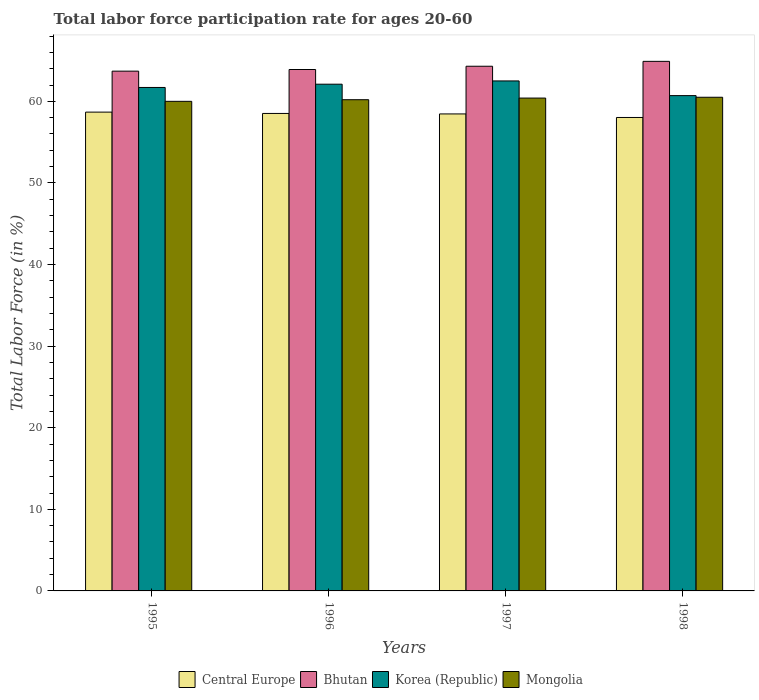Are the number of bars per tick equal to the number of legend labels?
Make the answer very short. Yes. Are the number of bars on each tick of the X-axis equal?
Provide a succinct answer. Yes. How many bars are there on the 2nd tick from the right?
Ensure brevity in your answer.  4. What is the label of the 4th group of bars from the left?
Make the answer very short. 1998. What is the labor force participation rate in Korea (Republic) in 1995?
Your answer should be very brief. 61.7. Across all years, what is the maximum labor force participation rate in Central Europe?
Offer a terse response. 58.68. Across all years, what is the minimum labor force participation rate in Korea (Republic)?
Your answer should be compact. 60.7. In which year was the labor force participation rate in Korea (Republic) maximum?
Give a very brief answer. 1997. In which year was the labor force participation rate in Mongolia minimum?
Your answer should be compact. 1995. What is the total labor force participation rate in Central Europe in the graph?
Offer a very short reply. 233.67. What is the difference between the labor force participation rate in Central Europe in 1996 and that in 1997?
Offer a terse response. 0.06. What is the difference between the labor force participation rate in Central Europe in 1998 and the labor force participation rate in Mongolia in 1995?
Ensure brevity in your answer.  -1.98. What is the average labor force participation rate in Mongolia per year?
Offer a very short reply. 60.28. In the year 1995, what is the difference between the labor force participation rate in Central Europe and labor force participation rate in Korea (Republic)?
Keep it short and to the point. -3.02. In how many years, is the labor force participation rate in Central Europe greater than 24 %?
Offer a terse response. 4. What is the ratio of the labor force participation rate in Korea (Republic) in 1996 to that in 1997?
Provide a short and direct response. 0.99. Is the labor force participation rate in Mongolia in 1995 less than that in 1998?
Your response must be concise. Yes. Is the difference between the labor force participation rate in Central Europe in 1996 and 1997 greater than the difference between the labor force participation rate in Korea (Republic) in 1996 and 1997?
Make the answer very short. Yes. What is the difference between the highest and the second highest labor force participation rate in Central Europe?
Offer a terse response. 0.16. What is the difference between the highest and the lowest labor force participation rate in Korea (Republic)?
Provide a short and direct response. 1.8. What does the 1st bar from the left in 1995 represents?
Your answer should be very brief. Central Europe. What does the 1st bar from the right in 1995 represents?
Offer a terse response. Mongolia. Is it the case that in every year, the sum of the labor force participation rate in Korea (Republic) and labor force participation rate in Bhutan is greater than the labor force participation rate in Mongolia?
Offer a very short reply. Yes. How many bars are there?
Your answer should be compact. 16. Are all the bars in the graph horizontal?
Make the answer very short. No. How many years are there in the graph?
Provide a short and direct response. 4. What is the difference between two consecutive major ticks on the Y-axis?
Your answer should be very brief. 10. Does the graph contain any zero values?
Your response must be concise. No. Does the graph contain grids?
Make the answer very short. No. Where does the legend appear in the graph?
Your response must be concise. Bottom center. How many legend labels are there?
Offer a terse response. 4. How are the legend labels stacked?
Your answer should be compact. Horizontal. What is the title of the graph?
Ensure brevity in your answer.  Total labor force participation rate for ages 20-60. What is the label or title of the X-axis?
Provide a succinct answer. Years. What is the Total Labor Force (in %) of Central Europe in 1995?
Give a very brief answer. 58.68. What is the Total Labor Force (in %) of Bhutan in 1995?
Ensure brevity in your answer.  63.7. What is the Total Labor Force (in %) in Korea (Republic) in 1995?
Provide a short and direct response. 61.7. What is the Total Labor Force (in %) of Mongolia in 1995?
Ensure brevity in your answer.  60. What is the Total Labor Force (in %) in Central Europe in 1996?
Your answer should be compact. 58.52. What is the Total Labor Force (in %) in Bhutan in 1996?
Make the answer very short. 63.9. What is the Total Labor Force (in %) in Korea (Republic) in 1996?
Offer a very short reply. 62.1. What is the Total Labor Force (in %) of Mongolia in 1996?
Your response must be concise. 60.2. What is the Total Labor Force (in %) of Central Europe in 1997?
Provide a short and direct response. 58.46. What is the Total Labor Force (in %) in Bhutan in 1997?
Provide a short and direct response. 64.3. What is the Total Labor Force (in %) in Korea (Republic) in 1997?
Provide a short and direct response. 62.5. What is the Total Labor Force (in %) in Mongolia in 1997?
Give a very brief answer. 60.4. What is the Total Labor Force (in %) of Central Europe in 1998?
Your answer should be very brief. 58.02. What is the Total Labor Force (in %) of Bhutan in 1998?
Make the answer very short. 64.9. What is the Total Labor Force (in %) of Korea (Republic) in 1998?
Provide a short and direct response. 60.7. What is the Total Labor Force (in %) of Mongolia in 1998?
Provide a short and direct response. 60.5. Across all years, what is the maximum Total Labor Force (in %) of Central Europe?
Keep it short and to the point. 58.68. Across all years, what is the maximum Total Labor Force (in %) in Bhutan?
Provide a short and direct response. 64.9. Across all years, what is the maximum Total Labor Force (in %) in Korea (Republic)?
Keep it short and to the point. 62.5. Across all years, what is the maximum Total Labor Force (in %) of Mongolia?
Make the answer very short. 60.5. Across all years, what is the minimum Total Labor Force (in %) of Central Europe?
Provide a succinct answer. 58.02. Across all years, what is the minimum Total Labor Force (in %) in Bhutan?
Ensure brevity in your answer.  63.7. Across all years, what is the minimum Total Labor Force (in %) of Korea (Republic)?
Your response must be concise. 60.7. Across all years, what is the minimum Total Labor Force (in %) of Mongolia?
Give a very brief answer. 60. What is the total Total Labor Force (in %) in Central Europe in the graph?
Keep it short and to the point. 233.67. What is the total Total Labor Force (in %) in Bhutan in the graph?
Your answer should be compact. 256.8. What is the total Total Labor Force (in %) of Korea (Republic) in the graph?
Provide a short and direct response. 247. What is the total Total Labor Force (in %) in Mongolia in the graph?
Your answer should be very brief. 241.1. What is the difference between the Total Labor Force (in %) of Central Europe in 1995 and that in 1996?
Keep it short and to the point. 0.16. What is the difference between the Total Labor Force (in %) in Bhutan in 1995 and that in 1996?
Provide a short and direct response. -0.2. What is the difference between the Total Labor Force (in %) in Central Europe in 1995 and that in 1997?
Ensure brevity in your answer.  0.22. What is the difference between the Total Labor Force (in %) in Korea (Republic) in 1995 and that in 1997?
Your answer should be very brief. -0.8. What is the difference between the Total Labor Force (in %) in Central Europe in 1995 and that in 1998?
Your answer should be compact. 0.66. What is the difference between the Total Labor Force (in %) in Bhutan in 1995 and that in 1998?
Give a very brief answer. -1.2. What is the difference between the Total Labor Force (in %) in Central Europe in 1996 and that in 1997?
Make the answer very short. 0.06. What is the difference between the Total Labor Force (in %) of Korea (Republic) in 1996 and that in 1997?
Ensure brevity in your answer.  -0.4. What is the difference between the Total Labor Force (in %) in Central Europe in 1996 and that in 1998?
Provide a succinct answer. 0.49. What is the difference between the Total Labor Force (in %) in Bhutan in 1996 and that in 1998?
Your answer should be very brief. -1. What is the difference between the Total Labor Force (in %) in Korea (Republic) in 1996 and that in 1998?
Provide a succinct answer. 1.4. What is the difference between the Total Labor Force (in %) of Central Europe in 1997 and that in 1998?
Your answer should be compact. 0.44. What is the difference between the Total Labor Force (in %) of Bhutan in 1997 and that in 1998?
Provide a short and direct response. -0.6. What is the difference between the Total Labor Force (in %) of Central Europe in 1995 and the Total Labor Force (in %) of Bhutan in 1996?
Make the answer very short. -5.22. What is the difference between the Total Labor Force (in %) of Central Europe in 1995 and the Total Labor Force (in %) of Korea (Republic) in 1996?
Your answer should be very brief. -3.42. What is the difference between the Total Labor Force (in %) in Central Europe in 1995 and the Total Labor Force (in %) in Mongolia in 1996?
Keep it short and to the point. -1.52. What is the difference between the Total Labor Force (in %) of Central Europe in 1995 and the Total Labor Force (in %) of Bhutan in 1997?
Ensure brevity in your answer.  -5.62. What is the difference between the Total Labor Force (in %) of Central Europe in 1995 and the Total Labor Force (in %) of Korea (Republic) in 1997?
Provide a short and direct response. -3.82. What is the difference between the Total Labor Force (in %) of Central Europe in 1995 and the Total Labor Force (in %) of Mongolia in 1997?
Offer a terse response. -1.72. What is the difference between the Total Labor Force (in %) in Bhutan in 1995 and the Total Labor Force (in %) in Korea (Republic) in 1997?
Provide a short and direct response. 1.2. What is the difference between the Total Labor Force (in %) of Central Europe in 1995 and the Total Labor Force (in %) of Bhutan in 1998?
Make the answer very short. -6.22. What is the difference between the Total Labor Force (in %) in Central Europe in 1995 and the Total Labor Force (in %) in Korea (Republic) in 1998?
Give a very brief answer. -2.02. What is the difference between the Total Labor Force (in %) in Central Europe in 1995 and the Total Labor Force (in %) in Mongolia in 1998?
Your answer should be very brief. -1.82. What is the difference between the Total Labor Force (in %) of Bhutan in 1995 and the Total Labor Force (in %) of Korea (Republic) in 1998?
Offer a very short reply. 3. What is the difference between the Total Labor Force (in %) of Korea (Republic) in 1995 and the Total Labor Force (in %) of Mongolia in 1998?
Give a very brief answer. 1.2. What is the difference between the Total Labor Force (in %) of Central Europe in 1996 and the Total Labor Force (in %) of Bhutan in 1997?
Provide a succinct answer. -5.78. What is the difference between the Total Labor Force (in %) of Central Europe in 1996 and the Total Labor Force (in %) of Korea (Republic) in 1997?
Your answer should be compact. -3.98. What is the difference between the Total Labor Force (in %) in Central Europe in 1996 and the Total Labor Force (in %) in Mongolia in 1997?
Give a very brief answer. -1.88. What is the difference between the Total Labor Force (in %) in Central Europe in 1996 and the Total Labor Force (in %) in Bhutan in 1998?
Your response must be concise. -6.38. What is the difference between the Total Labor Force (in %) of Central Europe in 1996 and the Total Labor Force (in %) of Korea (Republic) in 1998?
Your answer should be compact. -2.18. What is the difference between the Total Labor Force (in %) of Central Europe in 1996 and the Total Labor Force (in %) of Mongolia in 1998?
Your answer should be compact. -1.98. What is the difference between the Total Labor Force (in %) of Bhutan in 1996 and the Total Labor Force (in %) of Korea (Republic) in 1998?
Make the answer very short. 3.2. What is the difference between the Total Labor Force (in %) of Bhutan in 1996 and the Total Labor Force (in %) of Mongolia in 1998?
Your answer should be very brief. 3.4. What is the difference between the Total Labor Force (in %) of Central Europe in 1997 and the Total Labor Force (in %) of Bhutan in 1998?
Provide a succinct answer. -6.44. What is the difference between the Total Labor Force (in %) of Central Europe in 1997 and the Total Labor Force (in %) of Korea (Republic) in 1998?
Give a very brief answer. -2.24. What is the difference between the Total Labor Force (in %) of Central Europe in 1997 and the Total Labor Force (in %) of Mongolia in 1998?
Offer a terse response. -2.04. What is the difference between the Total Labor Force (in %) of Bhutan in 1997 and the Total Labor Force (in %) of Korea (Republic) in 1998?
Give a very brief answer. 3.6. What is the difference between the Total Labor Force (in %) of Bhutan in 1997 and the Total Labor Force (in %) of Mongolia in 1998?
Keep it short and to the point. 3.8. What is the average Total Labor Force (in %) in Central Europe per year?
Your answer should be very brief. 58.42. What is the average Total Labor Force (in %) in Bhutan per year?
Your response must be concise. 64.2. What is the average Total Labor Force (in %) in Korea (Republic) per year?
Make the answer very short. 61.75. What is the average Total Labor Force (in %) of Mongolia per year?
Ensure brevity in your answer.  60.27. In the year 1995, what is the difference between the Total Labor Force (in %) in Central Europe and Total Labor Force (in %) in Bhutan?
Ensure brevity in your answer.  -5.02. In the year 1995, what is the difference between the Total Labor Force (in %) in Central Europe and Total Labor Force (in %) in Korea (Republic)?
Ensure brevity in your answer.  -3.02. In the year 1995, what is the difference between the Total Labor Force (in %) of Central Europe and Total Labor Force (in %) of Mongolia?
Offer a very short reply. -1.32. In the year 1995, what is the difference between the Total Labor Force (in %) of Bhutan and Total Labor Force (in %) of Korea (Republic)?
Provide a short and direct response. 2. In the year 1995, what is the difference between the Total Labor Force (in %) in Bhutan and Total Labor Force (in %) in Mongolia?
Your answer should be very brief. 3.7. In the year 1995, what is the difference between the Total Labor Force (in %) in Korea (Republic) and Total Labor Force (in %) in Mongolia?
Your answer should be very brief. 1.7. In the year 1996, what is the difference between the Total Labor Force (in %) of Central Europe and Total Labor Force (in %) of Bhutan?
Offer a very short reply. -5.38. In the year 1996, what is the difference between the Total Labor Force (in %) in Central Europe and Total Labor Force (in %) in Korea (Republic)?
Give a very brief answer. -3.58. In the year 1996, what is the difference between the Total Labor Force (in %) of Central Europe and Total Labor Force (in %) of Mongolia?
Offer a terse response. -1.68. In the year 1996, what is the difference between the Total Labor Force (in %) of Bhutan and Total Labor Force (in %) of Korea (Republic)?
Your answer should be very brief. 1.8. In the year 1996, what is the difference between the Total Labor Force (in %) in Korea (Republic) and Total Labor Force (in %) in Mongolia?
Ensure brevity in your answer.  1.9. In the year 1997, what is the difference between the Total Labor Force (in %) in Central Europe and Total Labor Force (in %) in Bhutan?
Ensure brevity in your answer.  -5.84. In the year 1997, what is the difference between the Total Labor Force (in %) of Central Europe and Total Labor Force (in %) of Korea (Republic)?
Your answer should be compact. -4.04. In the year 1997, what is the difference between the Total Labor Force (in %) in Central Europe and Total Labor Force (in %) in Mongolia?
Give a very brief answer. -1.94. In the year 1997, what is the difference between the Total Labor Force (in %) in Bhutan and Total Labor Force (in %) in Mongolia?
Your answer should be compact. 3.9. In the year 1998, what is the difference between the Total Labor Force (in %) of Central Europe and Total Labor Force (in %) of Bhutan?
Your response must be concise. -6.88. In the year 1998, what is the difference between the Total Labor Force (in %) of Central Europe and Total Labor Force (in %) of Korea (Republic)?
Your answer should be compact. -2.68. In the year 1998, what is the difference between the Total Labor Force (in %) in Central Europe and Total Labor Force (in %) in Mongolia?
Your answer should be very brief. -2.48. In the year 1998, what is the difference between the Total Labor Force (in %) in Bhutan and Total Labor Force (in %) in Mongolia?
Offer a very short reply. 4.4. In the year 1998, what is the difference between the Total Labor Force (in %) in Korea (Republic) and Total Labor Force (in %) in Mongolia?
Your answer should be very brief. 0.2. What is the ratio of the Total Labor Force (in %) of Central Europe in 1995 to that in 1996?
Your answer should be very brief. 1. What is the ratio of the Total Labor Force (in %) of Korea (Republic) in 1995 to that in 1996?
Your answer should be very brief. 0.99. What is the ratio of the Total Labor Force (in %) in Bhutan in 1995 to that in 1997?
Give a very brief answer. 0.99. What is the ratio of the Total Labor Force (in %) of Korea (Republic) in 1995 to that in 1997?
Your answer should be compact. 0.99. What is the ratio of the Total Labor Force (in %) of Mongolia in 1995 to that in 1997?
Give a very brief answer. 0.99. What is the ratio of the Total Labor Force (in %) in Central Europe in 1995 to that in 1998?
Provide a succinct answer. 1.01. What is the ratio of the Total Labor Force (in %) of Bhutan in 1995 to that in 1998?
Keep it short and to the point. 0.98. What is the ratio of the Total Labor Force (in %) of Korea (Republic) in 1995 to that in 1998?
Your answer should be compact. 1.02. What is the ratio of the Total Labor Force (in %) in Mongolia in 1996 to that in 1997?
Your answer should be compact. 1. What is the ratio of the Total Labor Force (in %) of Central Europe in 1996 to that in 1998?
Offer a terse response. 1.01. What is the ratio of the Total Labor Force (in %) in Bhutan in 1996 to that in 1998?
Ensure brevity in your answer.  0.98. What is the ratio of the Total Labor Force (in %) in Korea (Republic) in 1996 to that in 1998?
Your response must be concise. 1.02. What is the ratio of the Total Labor Force (in %) in Mongolia in 1996 to that in 1998?
Your answer should be very brief. 0.99. What is the ratio of the Total Labor Force (in %) of Central Europe in 1997 to that in 1998?
Offer a very short reply. 1.01. What is the ratio of the Total Labor Force (in %) of Korea (Republic) in 1997 to that in 1998?
Keep it short and to the point. 1.03. What is the ratio of the Total Labor Force (in %) of Mongolia in 1997 to that in 1998?
Provide a succinct answer. 1. What is the difference between the highest and the second highest Total Labor Force (in %) in Central Europe?
Make the answer very short. 0.16. What is the difference between the highest and the second highest Total Labor Force (in %) of Korea (Republic)?
Your answer should be very brief. 0.4. What is the difference between the highest and the second highest Total Labor Force (in %) of Mongolia?
Your answer should be compact. 0.1. What is the difference between the highest and the lowest Total Labor Force (in %) of Central Europe?
Give a very brief answer. 0.66. What is the difference between the highest and the lowest Total Labor Force (in %) of Mongolia?
Keep it short and to the point. 0.5. 